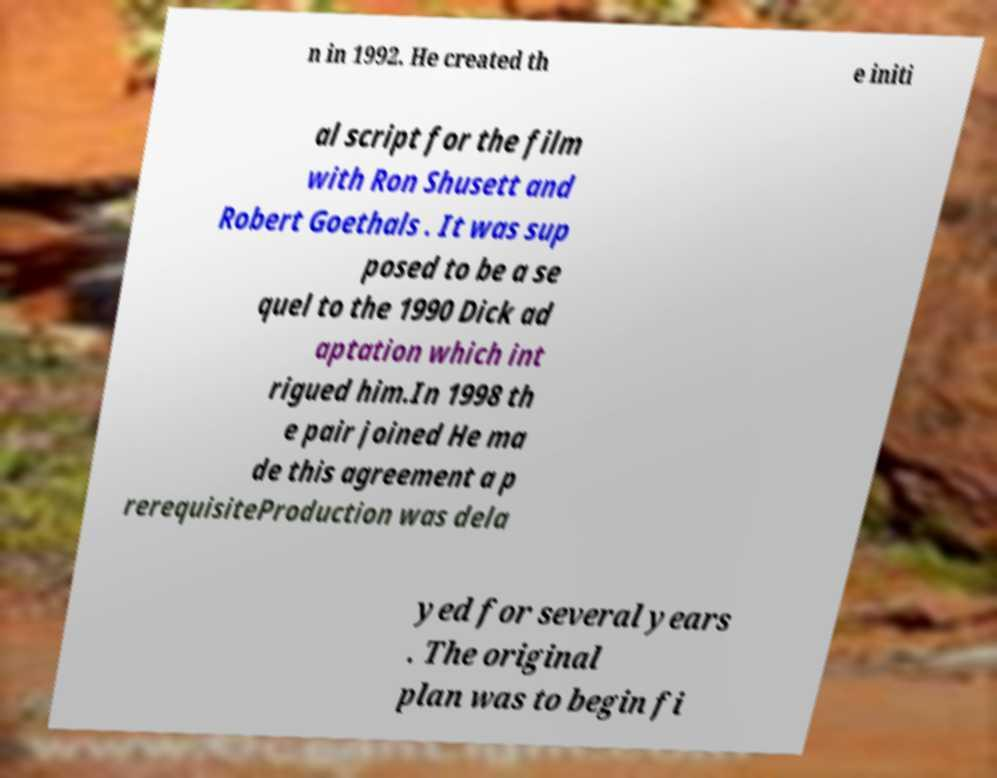Please identify and transcribe the text found in this image. n in 1992. He created th e initi al script for the film with Ron Shusett and Robert Goethals . It was sup posed to be a se quel to the 1990 Dick ad aptation which int rigued him.In 1998 th e pair joined He ma de this agreement a p rerequisiteProduction was dela yed for several years . The original plan was to begin fi 